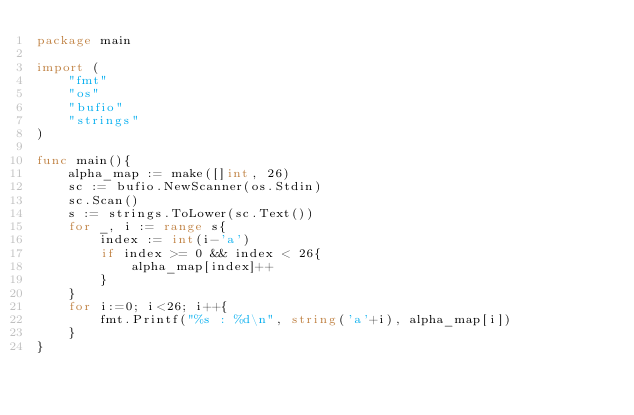Convert code to text. <code><loc_0><loc_0><loc_500><loc_500><_Go_>package main

import (
	"fmt"
	"os"
	"bufio"
	"strings"
)

func main(){
	alpha_map := make([]int, 26)
	sc := bufio.NewScanner(os.Stdin)
	sc.Scan()
	s := strings.ToLower(sc.Text())
	for _, i := range s{
		index := int(i-'a')
		if index >= 0 && index < 26{
			alpha_map[index]++
		}
	}
	for i:=0; i<26; i++{
		fmt.Printf("%s : %d\n", string('a'+i), alpha_map[i])
	}
}
</code> 